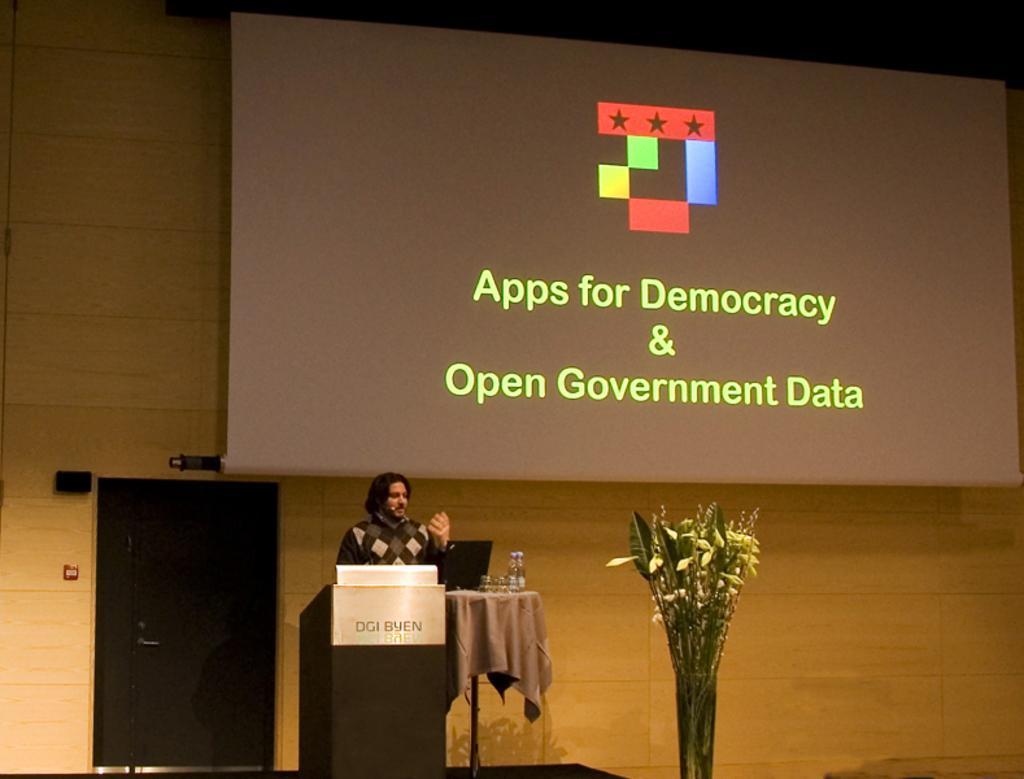Can you describe this image briefly? In this image there is a flower vase, there are glasses and a bottle on the table, there is a person standing near the podium , there is a screen. 